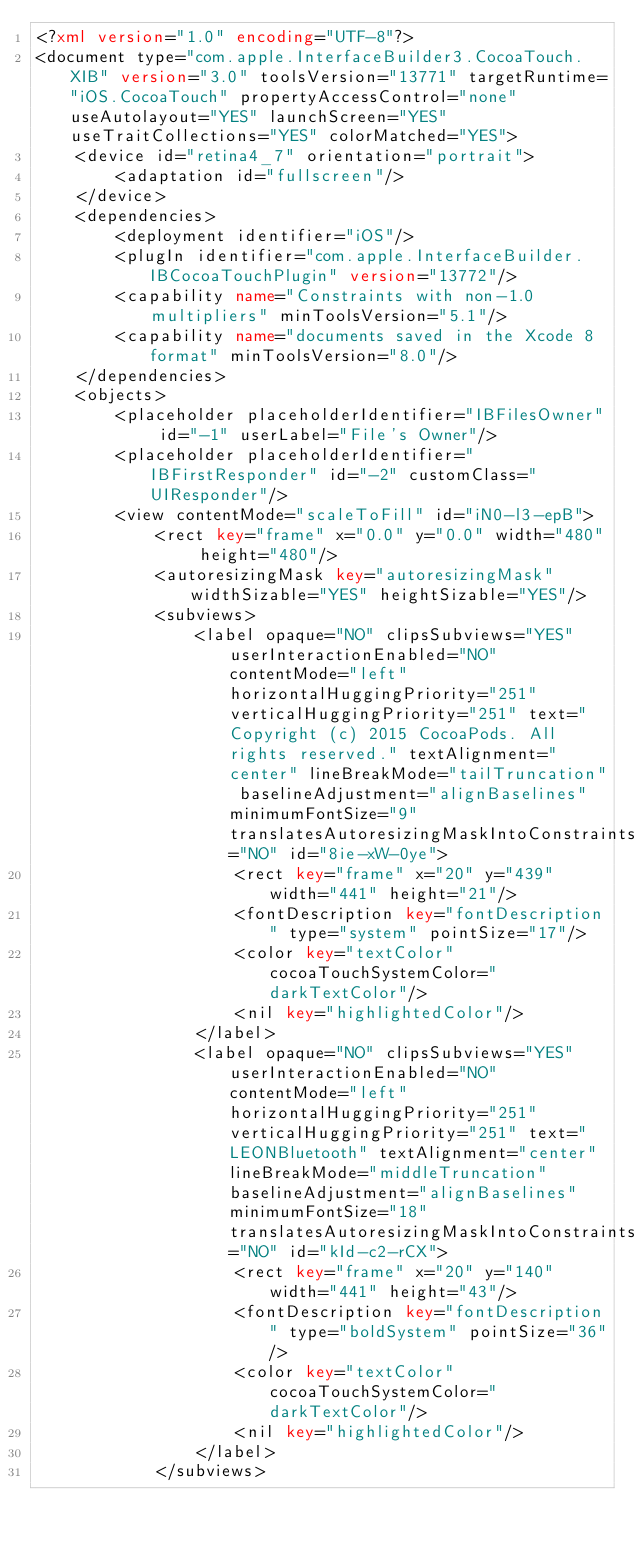<code> <loc_0><loc_0><loc_500><loc_500><_XML_><?xml version="1.0" encoding="UTF-8"?>
<document type="com.apple.InterfaceBuilder3.CocoaTouch.XIB" version="3.0" toolsVersion="13771" targetRuntime="iOS.CocoaTouch" propertyAccessControl="none" useAutolayout="YES" launchScreen="YES" useTraitCollections="YES" colorMatched="YES">
    <device id="retina4_7" orientation="portrait">
        <adaptation id="fullscreen"/>
    </device>
    <dependencies>
        <deployment identifier="iOS"/>
        <plugIn identifier="com.apple.InterfaceBuilder.IBCocoaTouchPlugin" version="13772"/>
        <capability name="Constraints with non-1.0 multipliers" minToolsVersion="5.1"/>
        <capability name="documents saved in the Xcode 8 format" minToolsVersion="8.0"/>
    </dependencies>
    <objects>
        <placeholder placeholderIdentifier="IBFilesOwner" id="-1" userLabel="File's Owner"/>
        <placeholder placeholderIdentifier="IBFirstResponder" id="-2" customClass="UIResponder"/>
        <view contentMode="scaleToFill" id="iN0-l3-epB">
            <rect key="frame" x="0.0" y="0.0" width="480" height="480"/>
            <autoresizingMask key="autoresizingMask" widthSizable="YES" heightSizable="YES"/>
            <subviews>
                <label opaque="NO" clipsSubviews="YES" userInteractionEnabled="NO" contentMode="left" horizontalHuggingPriority="251" verticalHuggingPriority="251" text="  Copyright (c) 2015 CocoaPods. All rights reserved." textAlignment="center" lineBreakMode="tailTruncation" baselineAdjustment="alignBaselines" minimumFontSize="9" translatesAutoresizingMaskIntoConstraints="NO" id="8ie-xW-0ye">
                    <rect key="frame" x="20" y="439" width="441" height="21"/>
                    <fontDescription key="fontDescription" type="system" pointSize="17"/>
                    <color key="textColor" cocoaTouchSystemColor="darkTextColor"/>
                    <nil key="highlightedColor"/>
                </label>
                <label opaque="NO" clipsSubviews="YES" userInteractionEnabled="NO" contentMode="left" horizontalHuggingPriority="251" verticalHuggingPriority="251" text="LEONBluetooth" textAlignment="center" lineBreakMode="middleTruncation" baselineAdjustment="alignBaselines" minimumFontSize="18" translatesAutoresizingMaskIntoConstraints="NO" id="kId-c2-rCX">
                    <rect key="frame" x="20" y="140" width="441" height="43"/>
                    <fontDescription key="fontDescription" type="boldSystem" pointSize="36"/>
                    <color key="textColor" cocoaTouchSystemColor="darkTextColor"/>
                    <nil key="highlightedColor"/>
                </label>
            </subviews></code> 